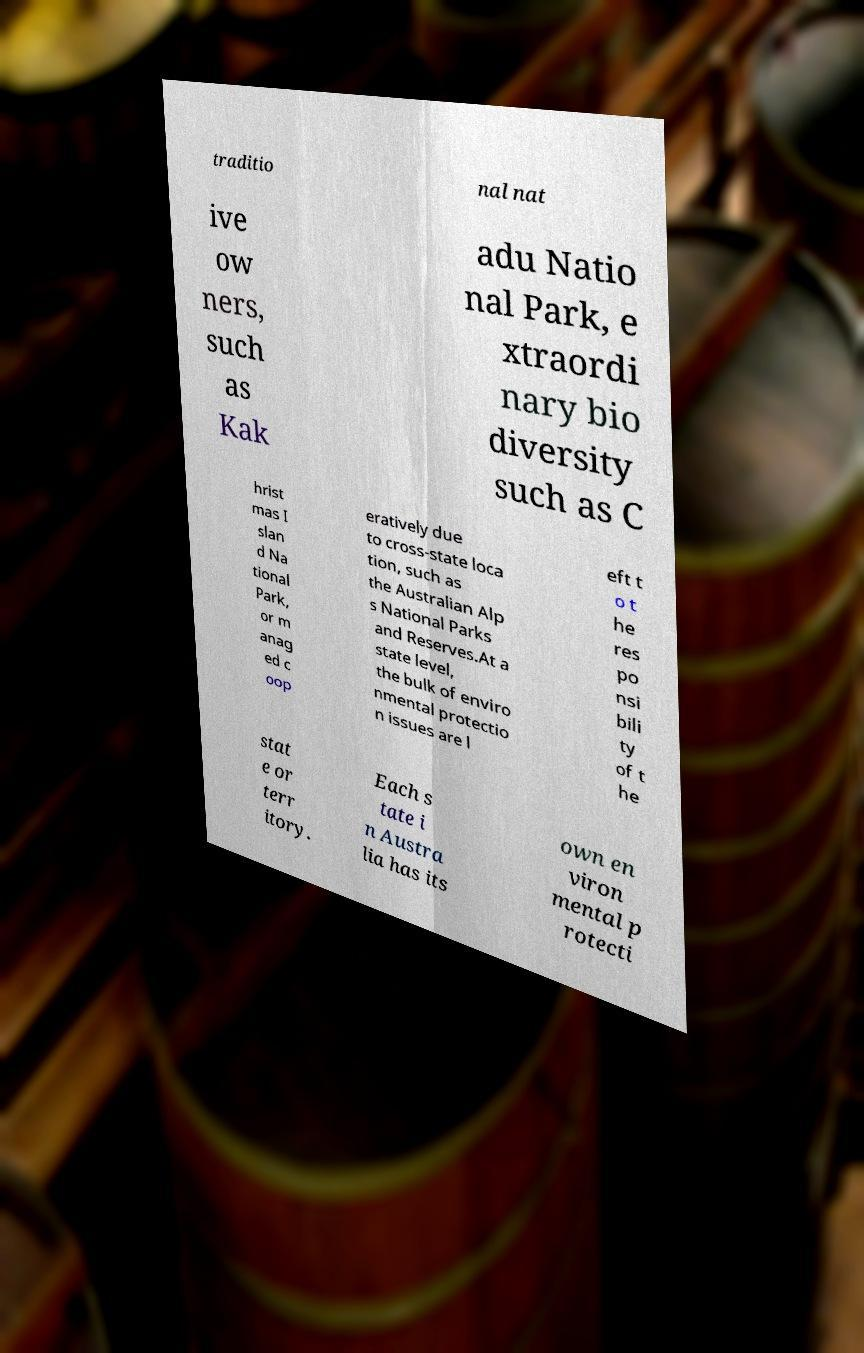There's text embedded in this image that I need extracted. Can you transcribe it verbatim? traditio nal nat ive ow ners, such as Kak adu Natio nal Park, e xtraordi nary bio diversity such as C hrist mas I slan d Na tional Park, or m anag ed c oop eratively due to cross-state loca tion, such as the Australian Alp s National Parks and Reserves.At a state level, the bulk of enviro nmental protectio n issues are l eft t o t he res po nsi bili ty of t he stat e or terr itory. Each s tate i n Austra lia has its own en viron mental p rotecti 